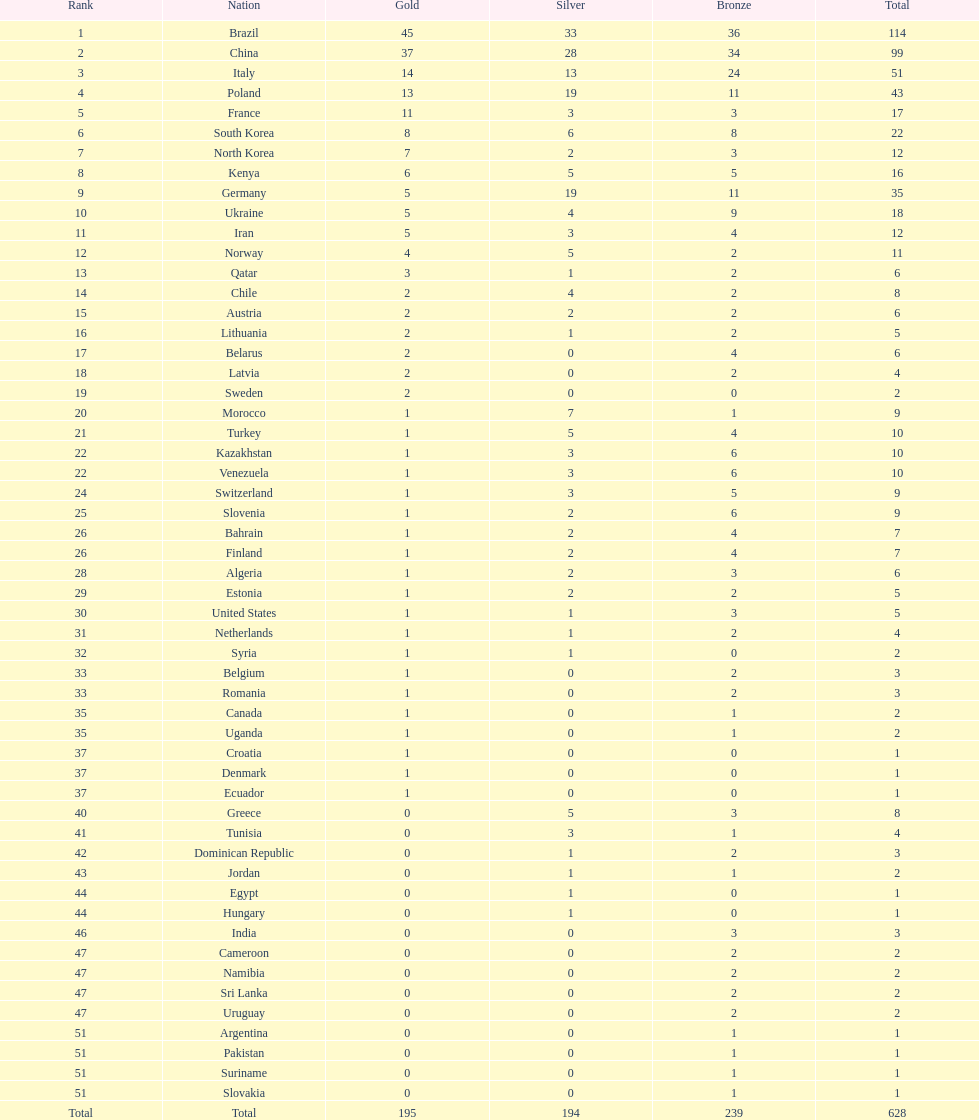What is the difference in medal count between south korea and north korea? 10. 